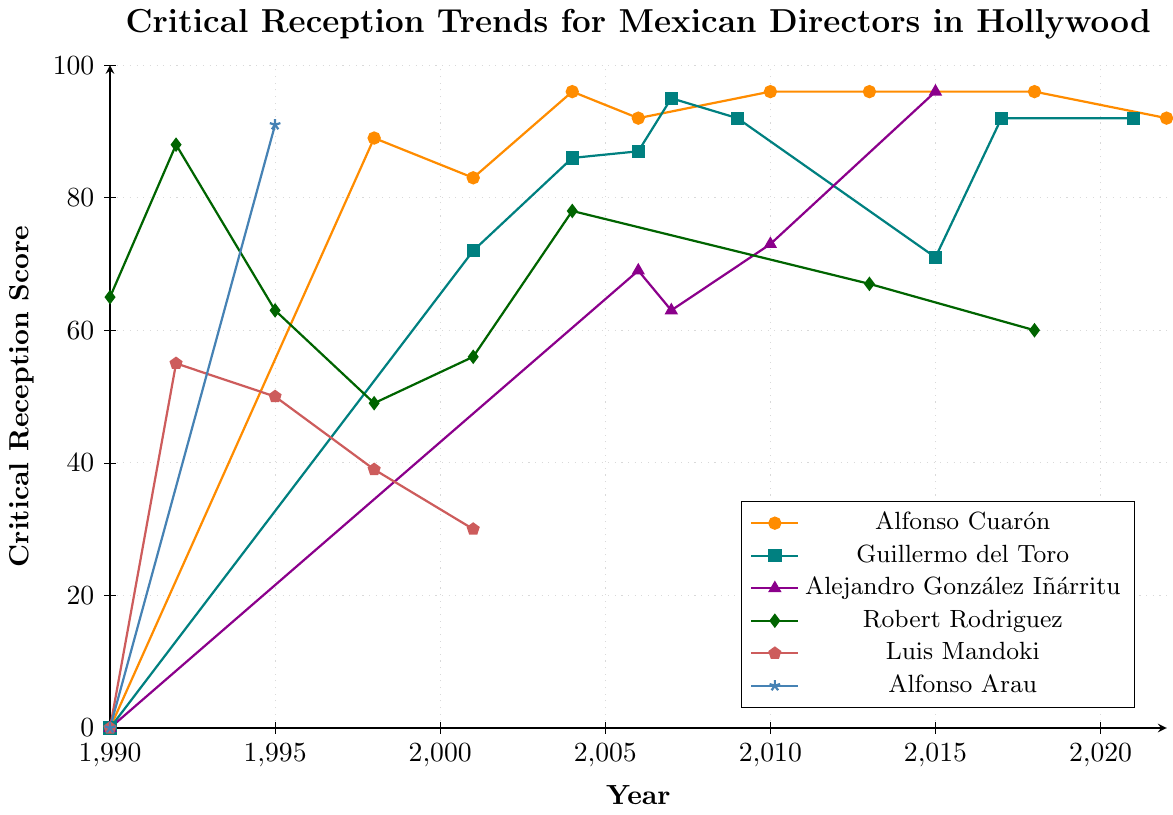When did Alfonso Cuarón first appear on the graph? The first appearance of Alfonso Cuarón on the graph is indicated by the point where his critical reception score changes from zero. According to the figure, he first appears in 1998 with a score of 89.
Answer: 1998 Who had a higher score in 2001, Guillermo del Toro or Robert Rodriguez? In 2001, Guillermo del Toro had a score of 72, while Robert Rodriguez had a score of 56. Comparing these two scores, Guillermo del Toro is higher.
Answer: Guillermo del Toro Which director showed the most consistent high score (above 90) over multiple years? Observing the values above 90 for each director, Alfonso Cuarón had scores of 96 in 2004, 2010, 2013, and 2018. Guillermo del Toro and Alejandro González Iñárritu had high scores above 90, but not as consistently. Thus, Alfonso Cuarón is the most consistent.
Answer: Alfonso Cuarón In what year did three directors have a critical reception score, and who were they? By inspecting the graph for the years where three plots are marked, it's found that in 2006, Alfonso Cuarón, Guillermo del Toro, and Alejandro González Iñárritu recorded scores of 92, 87, and 69, respectively.
Answer: 2006, Alfonso Cuarón, Guillermo del Toro, Alejandro González Iñárritu What is the sum of critical reception scores for Luis Mandoki from 1990 to 2022? Summing up Luis Mandoki's scores: 0 (1990) + 55 (1992) + 50 (1995) + 39 (1998) + 30 (2001) = 174.
Answer: 174 Compare the reception trends of Alfonso Cuarón and Alfonso Arau, and identify the maximum score for each. Alfonso Cuarón’s scores show many high points with his maximum being 96, while Alfonso Arau appeared with only two scores, 0 (1990) and 91 (1995). Hence, their maximum scores are 96 for Alfonso Cuarón and 91 for Alfonso Arau.
Answer: 96 (Cuaron), 91 (Arau) Which director did not have any scores after 2001? Referring to the graph plots, Luis Mandoki had his last recorded score in 2001 and does not appear thereafter.
Answer: Luis Mandoki How many times did Guillermo del Toro receive a score of exactly 92? Looking at the points for Guillermo del Toro marked on the graph, he received scores of exactly 92 in three years: 2009, 2017, and 2021.
Answer: 3 